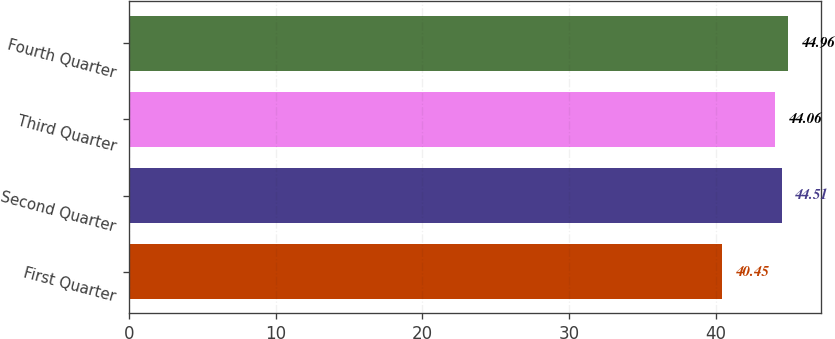Convert chart to OTSL. <chart><loc_0><loc_0><loc_500><loc_500><bar_chart><fcel>First Quarter<fcel>Second Quarter<fcel>Third Quarter<fcel>Fourth Quarter<nl><fcel>40.45<fcel>44.51<fcel>44.06<fcel>44.96<nl></chart> 